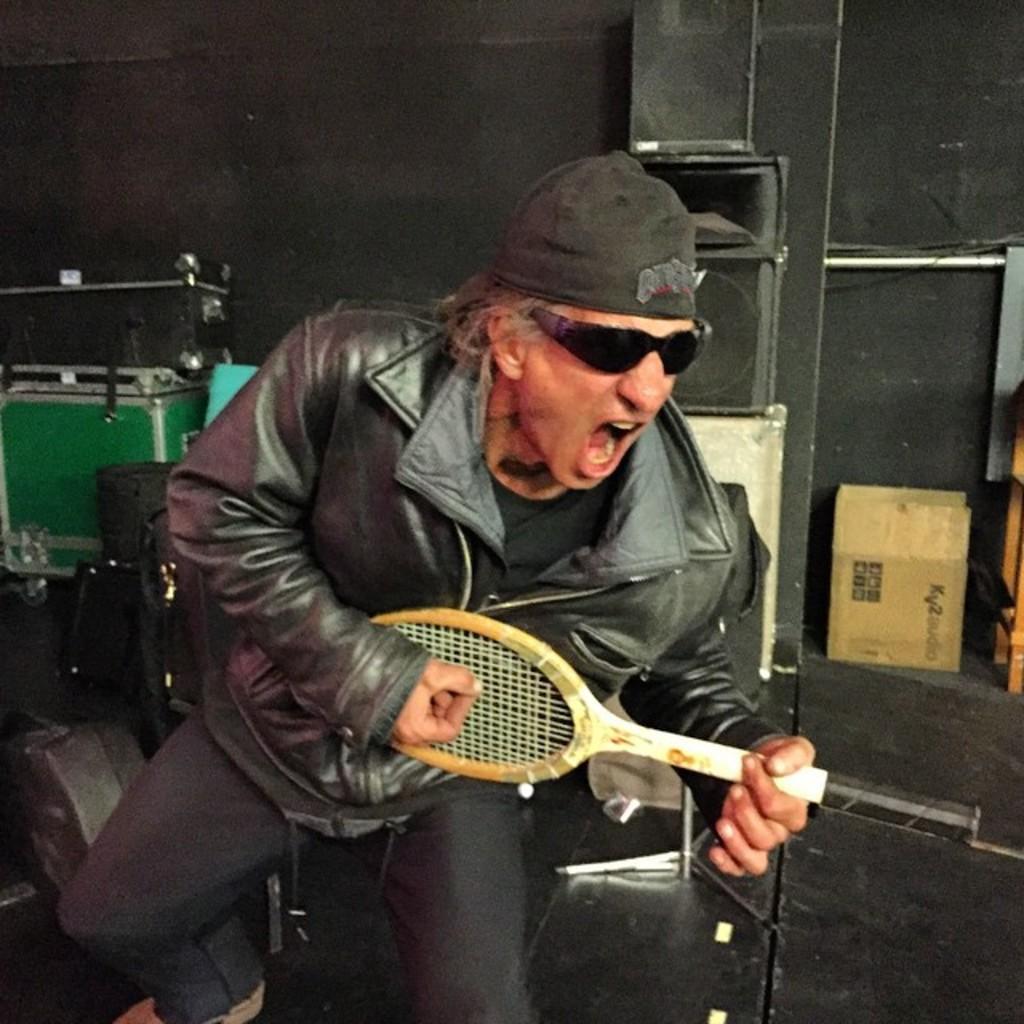How would you summarize this image in a sentence or two? In this image there is a person sitting, there is a person holding an object, there is a person singing, there is a chair truncated towards the bottom of the image, there are objects on the surface, there are objects truncated towards the right of the image, there are objects truncated towards the left of the image, the background of the image there is a black color wall truncated. 